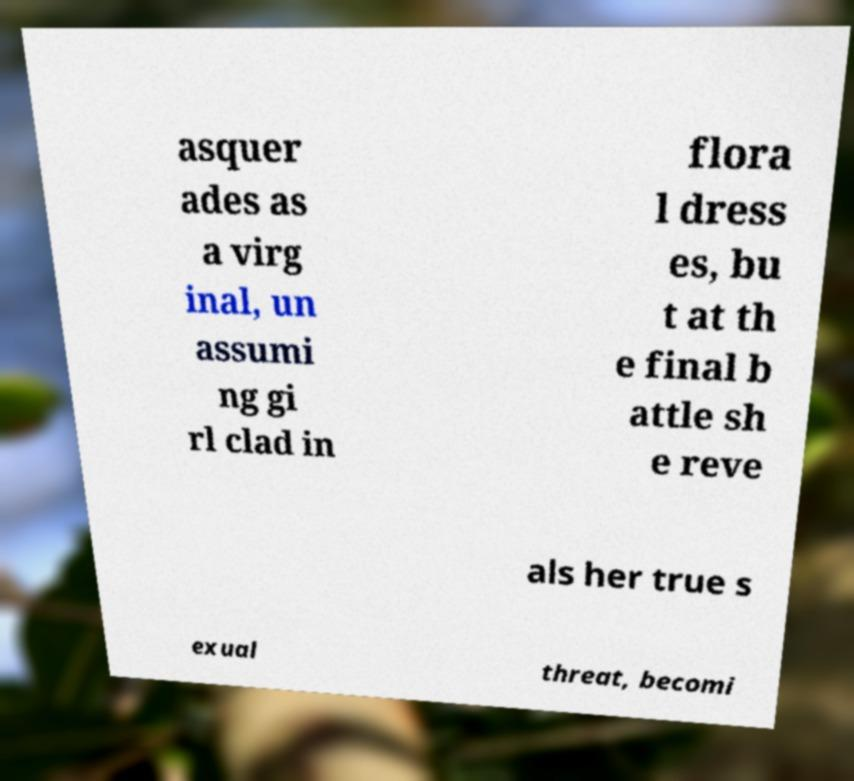Can you read and provide the text displayed in the image?This photo seems to have some interesting text. Can you extract and type it out for me? asquer ades as a virg inal, un assumi ng gi rl clad in flora l dress es, bu t at th e final b attle sh e reve als her true s exual threat, becomi 